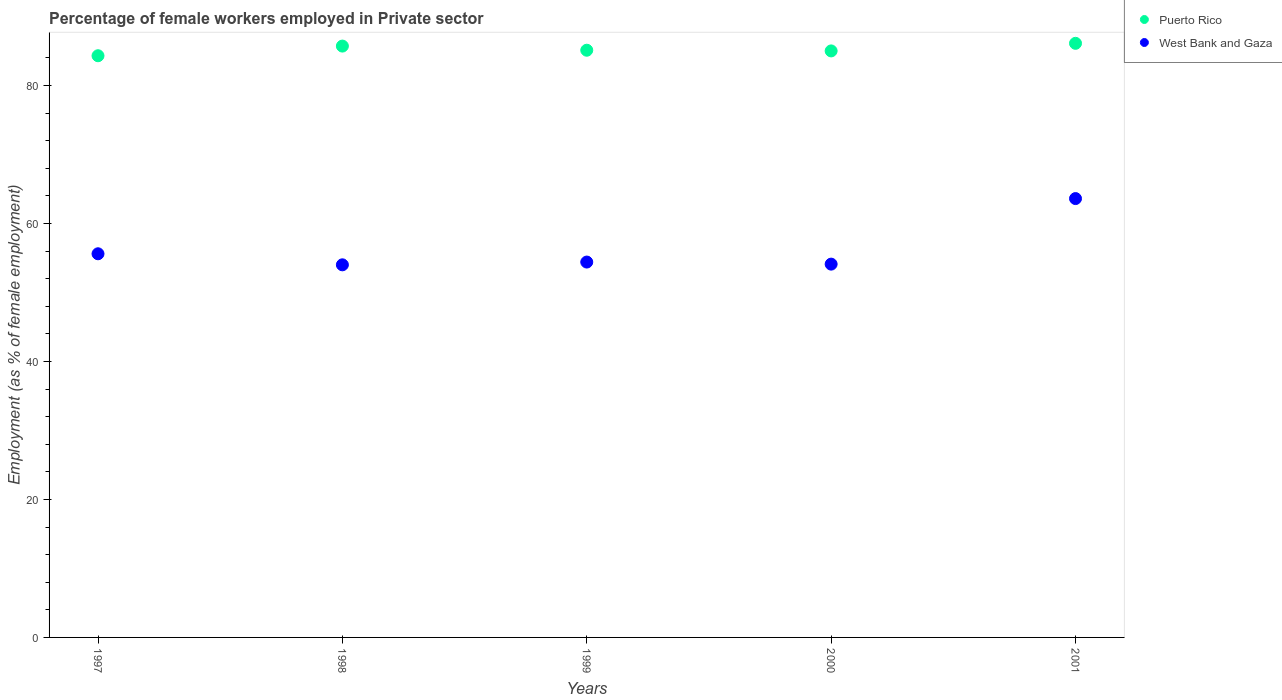Is the number of dotlines equal to the number of legend labels?
Provide a short and direct response. Yes. What is the percentage of females employed in Private sector in Puerto Rico in 1999?
Offer a terse response. 85.1. Across all years, what is the maximum percentage of females employed in Private sector in West Bank and Gaza?
Ensure brevity in your answer.  63.6. Across all years, what is the minimum percentage of females employed in Private sector in Puerto Rico?
Your answer should be very brief. 84.3. What is the total percentage of females employed in Private sector in Puerto Rico in the graph?
Offer a terse response. 426.2. What is the difference between the percentage of females employed in Private sector in Puerto Rico in 1998 and the percentage of females employed in Private sector in West Bank and Gaza in 1999?
Offer a very short reply. 31.3. What is the average percentage of females employed in Private sector in Puerto Rico per year?
Provide a succinct answer. 85.24. In the year 1997, what is the difference between the percentage of females employed in Private sector in Puerto Rico and percentage of females employed in Private sector in West Bank and Gaza?
Offer a very short reply. 28.7. What is the ratio of the percentage of females employed in Private sector in West Bank and Gaza in 1997 to that in 1999?
Give a very brief answer. 1.02. Is the percentage of females employed in Private sector in West Bank and Gaza in 1998 less than that in 2001?
Your answer should be compact. Yes. What is the difference between the highest and the second highest percentage of females employed in Private sector in Puerto Rico?
Offer a very short reply. 0.4. What is the difference between the highest and the lowest percentage of females employed in Private sector in Puerto Rico?
Your response must be concise. 1.8. In how many years, is the percentage of females employed in Private sector in West Bank and Gaza greater than the average percentage of females employed in Private sector in West Bank and Gaza taken over all years?
Your response must be concise. 1. Is the percentage of females employed in Private sector in Puerto Rico strictly less than the percentage of females employed in Private sector in West Bank and Gaza over the years?
Your response must be concise. No. How many dotlines are there?
Your answer should be very brief. 2. Are the values on the major ticks of Y-axis written in scientific E-notation?
Your answer should be compact. No. Does the graph contain grids?
Make the answer very short. No. What is the title of the graph?
Provide a succinct answer. Percentage of female workers employed in Private sector. What is the label or title of the Y-axis?
Your response must be concise. Employment (as % of female employment). What is the Employment (as % of female employment) in Puerto Rico in 1997?
Your answer should be very brief. 84.3. What is the Employment (as % of female employment) in West Bank and Gaza in 1997?
Provide a succinct answer. 55.6. What is the Employment (as % of female employment) in Puerto Rico in 1998?
Your answer should be compact. 85.7. What is the Employment (as % of female employment) of Puerto Rico in 1999?
Give a very brief answer. 85.1. What is the Employment (as % of female employment) in West Bank and Gaza in 1999?
Keep it short and to the point. 54.4. What is the Employment (as % of female employment) in West Bank and Gaza in 2000?
Provide a succinct answer. 54.1. What is the Employment (as % of female employment) in Puerto Rico in 2001?
Offer a terse response. 86.1. What is the Employment (as % of female employment) of West Bank and Gaza in 2001?
Offer a terse response. 63.6. Across all years, what is the maximum Employment (as % of female employment) of Puerto Rico?
Provide a short and direct response. 86.1. Across all years, what is the maximum Employment (as % of female employment) in West Bank and Gaza?
Provide a succinct answer. 63.6. Across all years, what is the minimum Employment (as % of female employment) of Puerto Rico?
Give a very brief answer. 84.3. What is the total Employment (as % of female employment) in Puerto Rico in the graph?
Give a very brief answer. 426.2. What is the total Employment (as % of female employment) in West Bank and Gaza in the graph?
Offer a very short reply. 281.7. What is the difference between the Employment (as % of female employment) in Puerto Rico in 1997 and that in 1999?
Offer a terse response. -0.8. What is the difference between the Employment (as % of female employment) in West Bank and Gaza in 1997 and that in 1999?
Ensure brevity in your answer.  1.2. What is the difference between the Employment (as % of female employment) in Puerto Rico in 1997 and that in 2000?
Your answer should be compact. -0.7. What is the difference between the Employment (as % of female employment) of Puerto Rico in 1997 and that in 2001?
Make the answer very short. -1.8. What is the difference between the Employment (as % of female employment) of West Bank and Gaza in 1997 and that in 2001?
Your answer should be very brief. -8. What is the difference between the Employment (as % of female employment) of Puerto Rico in 1998 and that in 1999?
Your answer should be very brief. 0.6. What is the difference between the Employment (as % of female employment) in Puerto Rico in 1998 and that in 2000?
Make the answer very short. 0.7. What is the difference between the Employment (as % of female employment) of West Bank and Gaza in 1998 and that in 2000?
Keep it short and to the point. -0.1. What is the difference between the Employment (as % of female employment) of Puerto Rico in 1998 and that in 2001?
Make the answer very short. -0.4. What is the difference between the Employment (as % of female employment) in West Bank and Gaza in 1998 and that in 2001?
Ensure brevity in your answer.  -9.6. What is the difference between the Employment (as % of female employment) in West Bank and Gaza in 1999 and that in 2000?
Ensure brevity in your answer.  0.3. What is the difference between the Employment (as % of female employment) in Puerto Rico in 1999 and that in 2001?
Keep it short and to the point. -1. What is the difference between the Employment (as % of female employment) of West Bank and Gaza in 1999 and that in 2001?
Your answer should be compact. -9.2. What is the difference between the Employment (as % of female employment) in Puerto Rico in 2000 and that in 2001?
Offer a very short reply. -1.1. What is the difference between the Employment (as % of female employment) in West Bank and Gaza in 2000 and that in 2001?
Keep it short and to the point. -9.5. What is the difference between the Employment (as % of female employment) of Puerto Rico in 1997 and the Employment (as % of female employment) of West Bank and Gaza in 1998?
Offer a terse response. 30.3. What is the difference between the Employment (as % of female employment) of Puerto Rico in 1997 and the Employment (as % of female employment) of West Bank and Gaza in 1999?
Offer a terse response. 29.9. What is the difference between the Employment (as % of female employment) in Puerto Rico in 1997 and the Employment (as % of female employment) in West Bank and Gaza in 2000?
Your answer should be compact. 30.2. What is the difference between the Employment (as % of female employment) in Puerto Rico in 1997 and the Employment (as % of female employment) in West Bank and Gaza in 2001?
Provide a short and direct response. 20.7. What is the difference between the Employment (as % of female employment) in Puerto Rico in 1998 and the Employment (as % of female employment) in West Bank and Gaza in 1999?
Offer a very short reply. 31.3. What is the difference between the Employment (as % of female employment) of Puerto Rico in 1998 and the Employment (as % of female employment) of West Bank and Gaza in 2000?
Keep it short and to the point. 31.6. What is the difference between the Employment (as % of female employment) in Puerto Rico in 1998 and the Employment (as % of female employment) in West Bank and Gaza in 2001?
Ensure brevity in your answer.  22.1. What is the difference between the Employment (as % of female employment) in Puerto Rico in 1999 and the Employment (as % of female employment) in West Bank and Gaza in 2000?
Make the answer very short. 31. What is the difference between the Employment (as % of female employment) in Puerto Rico in 1999 and the Employment (as % of female employment) in West Bank and Gaza in 2001?
Make the answer very short. 21.5. What is the difference between the Employment (as % of female employment) of Puerto Rico in 2000 and the Employment (as % of female employment) of West Bank and Gaza in 2001?
Your response must be concise. 21.4. What is the average Employment (as % of female employment) in Puerto Rico per year?
Offer a terse response. 85.24. What is the average Employment (as % of female employment) of West Bank and Gaza per year?
Your answer should be compact. 56.34. In the year 1997, what is the difference between the Employment (as % of female employment) in Puerto Rico and Employment (as % of female employment) in West Bank and Gaza?
Your response must be concise. 28.7. In the year 1998, what is the difference between the Employment (as % of female employment) of Puerto Rico and Employment (as % of female employment) of West Bank and Gaza?
Provide a succinct answer. 31.7. In the year 1999, what is the difference between the Employment (as % of female employment) of Puerto Rico and Employment (as % of female employment) of West Bank and Gaza?
Your response must be concise. 30.7. In the year 2000, what is the difference between the Employment (as % of female employment) of Puerto Rico and Employment (as % of female employment) of West Bank and Gaza?
Keep it short and to the point. 30.9. What is the ratio of the Employment (as % of female employment) in Puerto Rico in 1997 to that in 1998?
Offer a terse response. 0.98. What is the ratio of the Employment (as % of female employment) of West Bank and Gaza in 1997 to that in 1998?
Keep it short and to the point. 1.03. What is the ratio of the Employment (as % of female employment) in Puerto Rico in 1997 to that in 1999?
Provide a succinct answer. 0.99. What is the ratio of the Employment (as % of female employment) in West Bank and Gaza in 1997 to that in 1999?
Your answer should be compact. 1.02. What is the ratio of the Employment (as % of female employment) in West Bank and Gaza in 1997 to that in 2000?
Your answer should be compact. 1.03. What is the ratio of the Employment (as % of female employment) of Puerto Rico in 1997 to that in 2001?
Provide a succinct answer. 0.98. What is the ratio of the Employment (as % of female employment) in West Bank and Gaza in 1997 to that in 2001?
Offer a very short reply. 0.87. What is the ratio of the Employment (as % of female employment) in Puerto Rico in 1998 to that in 1999?
Make the answer very short. 1.01. What is the ratio of the Employment (as % of female employment) in West Bank and Gaza in 1998 to that in 1999?
Ensure brevity in your answer.  0.99. What is the ratio of the Employment (as % of female employment) in Puerto Rico in 1998 to that in 2000?
Your answer should be very brief. 1.01. What is the ratio of the Employment (as % of female employment) in West Bank and Gaza in 1998 to that in 2000?
Your answer should be very brief. 1. What is the ratio of the Employment (as % of female employment) in West Bank and Gaza in 1998 to that in 2001?
Make the answer very short. 0.85. What is the ratio of the Employment (as % of female employment) of Puerto Rico in 1999 to that in 2000?
Offer a terse response. 1. What is the ratio of the Employment (as % of female employment) in Puerto Rico in 1999 to that in 2001?
Give a very brief answer. 0.99. What is the ratio of the Employment (as % of female employment) of West Bank and Gaza in 1999 to that in 2001?
Give a very brief answer. 0.86. What is the ratio of the Employment (as % of female employment) of Puerto Rico in 2000 to that in 2001?
Ensure brevity in your answer.  0.99. What is the ratio of the Employment (as % of female employment) in West Bank and Gaza in 2000 to that in 2001?
Provide a succinct answer. 0.85. What is the difference between the highest and the second highest Employment (as % of female employment) in Puerto Rico?
Offer a very short reply. 0.4. What is the difference between the highest and the second highest Employment (as % of female employment) of West Bank and Gaza?
Offer a very short reply. 8. 